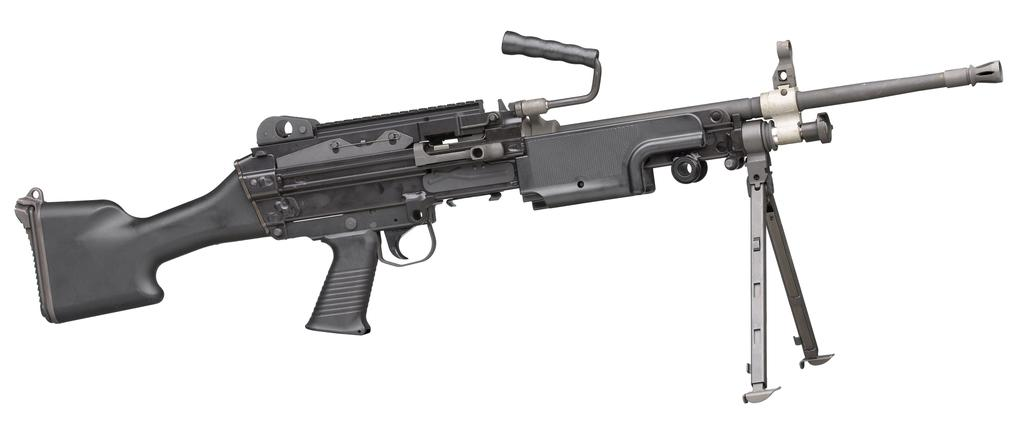What type of weapon is present in the image? There is a machine gun in the image. What type of cart is being pulled by the scarecrow in the image? There is no cart or scarecrow present in the image; it only features a machine gun. 